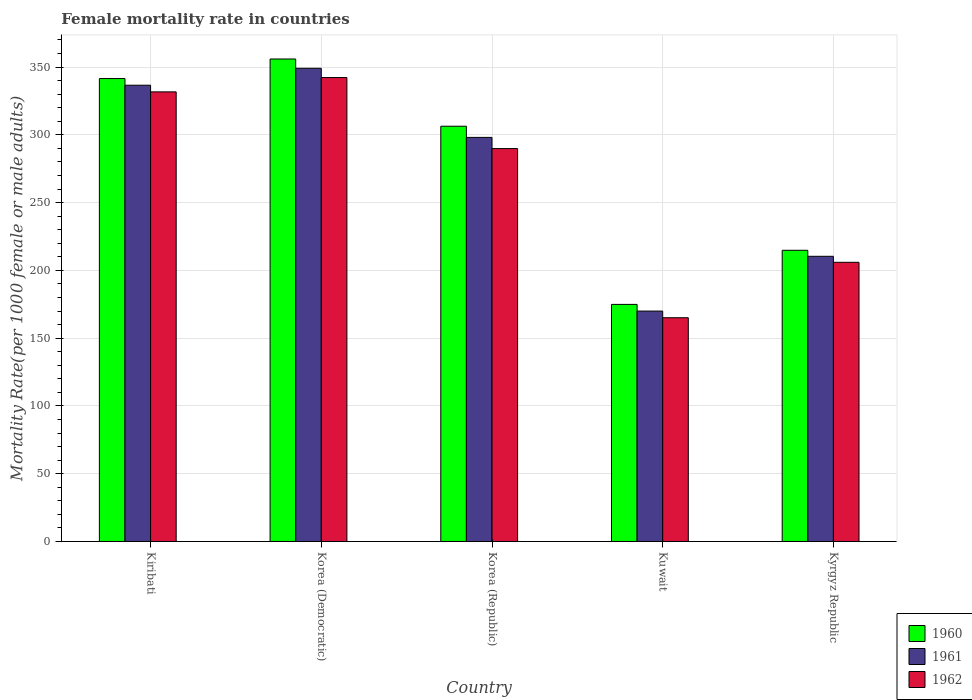How many groups of bars are there?
Give a very brief answer. 5. Are the number of bars on each tick of the X-axis equal?
Ensure brevity in your answer.  Yes. What is the label of the 5th group of bars from the left?
Ensure brevity in your answer.  Kyrgyz Republic. What is the female mortality rate in 1960 in Kuwait?
Your answer should be compact. 174.91. Across all countries, what is the maximum female mortality rate in 1961?
Ensure brevity in your answer.  349.13. Across all countries, what is the minimum female mortality rate in 1960?
Provide a short and direct response. 174.91. In which country was the female mortality rate in 1962 maximum?
Offer a terse response. Korea (Democratic). In which country was the female mortality rate in 1961 minimum?
Offer a terse response. Kuwait. What is the total female mortality rate in 1960 in the graph?
Keep it short and to the point. 1393.64. What is the difference between the female mortality rate in 1962 in Korea (Republic) and that in Kuwait?
Your response must be concise. 124.8. What is the difference between the female mortality rate in 1961 in Kyrgyz Republic and the female mortality rate in 1962 in Korea (Democratic)?
Your answer should be very brief. -131.89. What is the average female mortality rate in 1962 per country?
Offer a terse response. 266.99. What is the difference between the female mortality rate of/in 1960 and female mortality rate of/in 1961 in Kiribati?
Keep it short and to the point. 4.91. In how many countries, is the female mortality rate in 1961 greater than 330?
Make the answer very short. 2. What is the ratio of the female mortality rate in 1962 in Kiribati to that in Korea (Republic)?
Keep it short and to the point. 1.14. Is the difference between the female mortality rate in 1960 in Kiribati and Kuwait greater than the difference between the female mortality rate in 1961 in Kiribati and Kuwait?
Your answer should be very brief. No. What is the difference between the highest and the second highest female mortality rate in 1961?
Provide a succinct answer. 38.5. What is the difference between the highest and the lowest female mortality rate in 1962?
Ensure brevity in your answer.  177.21. Is the sum of the female mortality rate in 1962 in Kuwait and Kyrgyz Republic greater than the maximum female mortality rate in 1961 across all countries?
Provide a short and direct response. Yes. What does the 3rd bar from the left in Korea (Democratic) represents?
Make the answer very short. 1962. Is it the case that in every country, the sum of the female mortality rate in 1962 and female mortality rate in 1961 is greater than the female mortality rate in 1960?
Keep it short and to the point. Yes. How many bars are there?
Give a very brief answer. 15. Are all the bars in the graph horizontal?
Offer a very short reply. No. Does the graph contain any zero values?
Your response must be concise. No. How are the legend labels stacked?
Your answer should be compact. Vertical. What is the title of the graph?
Make the answer very short. Female mortality rate in countries. What is the label or title of the Y-axis?
Ensure brevity in your answer.  Mortality Rate(per 1000 female or male adults). What is the Mortality Rate(per 1000 female or male adults) of 1960 in Kiribati?
Provide a succinct answer. 341.55. What is the Mortality Rate(per 1000 female or male adults) of 1961 in Kiribati?
Offer a very short reply. 336.63. What is the Mortality Rate(per 1000 female or male adults) in 1962 in Kiribati?
Ensure brevity in your answer.  331.72. What is the Mortality Rate(per 1000 female or male adults) in 1960 in Korea (Democratic)?
Make the answer very short. 355.97. What is the Mortality Rate(per 1000 female or male adults) of 1961 in Korea (Democratic)?
Offer a very short reply. 349.13. What is the Mortality Rate(per 1000 female or male adults) in 1962 in Korea (Democratic)?
Provide a short and direct response. 342.29. What is the Mortality Rate(per 1000 female or male adults) in 1960 in Korea (Republic)?
Provide a short and direct response. 306.37. What is the Mortality Rate(per 1000 female or male adults) of 1961 in Korea (Republic)?
Keep it short and to the point. 298.13. What is the Mortality Rate(per 1000 female or male adults) of 1962 in Korea (Republic)?
Your response must be concise. 289.88. What is the Mortality Rate(per 1000 female or male adults) of 1960 in Kuwait?
Provide a short and direct response. 174.91. What is the Mortality Rate(per 1000 female or male adults) in 1961 in Kuwait?
Ensure brevity in your answer.  169.99. What is the Mortality Rate(per 1000 female or male adults) in 1962 in Kuwait?
Offer a very short reply. 165.08. What is the Mortality Rate(per 1000 female or male adults) in 1960 in Kyrgyz Republic?
Make the answer very short. 214.84. What is the Mortality Rate(per 1000 female or male adults) of 1961 in Kyrgyz Republic?
Provide a succinct answer. 210.4. What is the Mortality Rate(per 1000 female or male adults) of 1962 in Kyrgyz Republic?
Make the answer very short. 205.97. Across all countries, what is the maximum Mortality Rate(per 1000 female or male adults) of 1960?
Your answer should be compact. 355.97. Across all countries, what is the maximum Mortality Rate(per 1000 female or male adults) of 1961?
Provide a succinct answer. 349.13. Across all countries, what is the maximum Mortality Rate(per 1000 female or male adults) in 1962?
Provide a short and direct response. 342.29. Across all countries, what is the minimum Mortality Rate(per 1000 female or male adults) of 1960?
Your response must be concise. 174.91. Across all countries, what is the minimum Mortality Rate(per 1000 female or male adults) in 1961?
Provide a succinct answer. 169.99. Across all countries, what is the minimum Mortality Rate(per 1000 female or male adults) in 1962?
Offer a terse response. 165.08. What is the total Mortality Rate(per 1000 female or male adults) in 1960 in the graph?
Make the answer very short. 1393.64. What is the total Mortality Rate(per 1000 female or male adults) in 1961 in the graph?
Offer a terse response. 1364.29. What is the total Mortality Rate(per 1000 female or male adults) of 1962 in the graph?
Offer a terse response. 1334.93. What is the difference between the Mortality Rate(per 1000 female or male adults) in 1960 in Kiribati and that in Korea (Democratic)?
Keep it short and to the point. -14.43. What is the difference between the Mortality Rate(per 1000 female or male adults) in 1961 in Kiribati and that in Korea (Democratic)?
Your answer should be compact. -12.5. What is the difference between the Mortality Rate(per 1000 female or male adults) in 1962 in Kiribati and that in Korea (Democratic)?
Keep it short and to the point. -10.57. What is the difference between the Mortality Rate(per 1000 female or male adults) of 1960 in Kiribati and that in Korea (Republic)?
Your response must be concise. 35.17. What is the difference between the Mortality Rate(per 1000 female or male adults) of 1961 in Kiribati and that in Korea (Republic)?
Offer a terse response. 38.5. What is the difference between the Mortality Rate(per 1000 female or male adults) of 1962 in Kiribati and that in Korea (Republic)?
Your answer should be compact. 41.84. What is the difference between the Mortality Rate(per 1000 female or male adults) in 1960 in Kiribati and that in Kuwait?
Keep it short and to the point. 166.63. What is the difference between the Mortality Rate(per 1000 female or male adults) in 1961 in Kiribati and that in Kuwait?
Give a very brief answer. 166.64. What is the difference between the Mortality Rate(per 1000 female or male adults) in 1962 in Kiribati and that in Kuwait?
Give a very brief answer. 166.64. What is the difference between the Mortality Rate(per 1000 female or male adults) in 1960 in Kiribati and that in Kyrgyz Republic?
Offer a very short reply. 126.71. What is the difference between the Mortality Rate(per 1000 female or male adults) in 1961 in Kiribati and that in Kyrgyz Republic?
Your answer should be compact. 126.23. What is the difference between the Mortality Rate(per 1000 female or male adults) of 1962 in Kiribati and that in Kyrgyz Republic?
Offer a terse response. 125.75. What is the difference between the Mortality Rate(per 1000 female or male adults) in 1960 in Korea (Democratic) and that in Korea (Republic)?
Your response must be concise. 49.6. What is the difference between the Mortality Rate(per 1000 female or male adults) in 1961 in Korea (Democratic) and that in Korea (Republic)?
Provide a succinct answer. 51. What is the difference between the Mortality Rate(per 1000 female or male adults) in 1962 in Korea (Democratic) and that in Korea (Republic)?
Make the answer very short. 52.41. What is the difference between the Mortality Rate(per 1000 female or male adults) of 1960 in Korea (Democratic) and that in Kuwait?
Keep it short and to the point. 181.06. What is the difference between the Mortality Rate(per 1000 female or male adults) in 1961 in Korea (Democratic) and that in Kuwait?
Provide a succinct answer. 179.14. What is the difference between the Mortality Rate(per 1000 female or male adults) in 1962 in Korea (Democratic) and that in Kuwait?
Ensure brevity in your answer.  177.21. What is the difference between the Mortality Rate(per 1000 female or male adults) in 1960 in Korea (Democratic) and that in Kyrgyz Republic?
Your response must be concise. 141.13. What is the difference between the Mortality Rate(per 1000 female or male adults) of 1961 in Korea (Democratic) and that in Kyrgyz Republic?
Offer a very short reply. 138.73. What is the difference between the Mortality Rate(per 1000 female or male adults) in 1962 in Korea (Democratic) and that in Kyrgyz Republic?
Ensure brevity in your answer.  136.32. What is the difference between the Mortality Rate(per 1000 female or male adults) of 1960 in Korea (Republic) and that in Kuwait?
Provide a succinct answer. 131.46. What is the difference between the Mortality Rate(per 1000 female or male adults) of 1961 in Korea (Republic) and that in Kuwait?
Offer a terse response. 128.13. What is the difference between the Mortality Rate(per 1000 female or male adults) in 1962 in Korea (Republic) and that in Kuwait?
Provide a short and direct response. 124.8. What is the difference between the Mortality Rate(per 1000 female or male adults) in 1960 in Korea (Republic) and that in Kyrgyz Republic?
Give a very brief answer. 91.54. What is the difference between the Mortality Rate(per 1000 female or male adults) of 1961 in Korea (Republic) and that in Kyrgyz Republic?
Offer a terse response. 87.73. What is the difference between the Mortality Rate(per 1000 female or male adults) of 1962 in Korea (Republic) and that in Kyrgyz Republic?
Offer a terse response. 83.91. What is the difference between the Mortality Rate(per 1000 female or male adults) in 1960 in Kuwait and that in Kyrgyz Republic?
Your answer should be compact. -39.93. What is the difference between the Mortality Rate(per 1000 female or male adults) of 1961 in Kuwait and that in Kyrgyz Republic?
Make the answer very short. -40.41. What is the difference between the Mortality Rate(per 1000 female or male adults) in 1962 in Kuwait and that in Kyrgyz Republic?
Provide a short and direct response. -40.89. What is the difference between the Mortality Rate(per 1000 female or male adults) of 1960 in Kiribati and the Mortality Rate(per 1000 female or male adults) of 1961 in Korea (Democratic)?
Offer a terse response. -7.59. What is the difference between the Mortality Rate(per 1000 female or male adults) of 1960 in Kiribati and the Mortality Rate(per 1000 female or male adults) of 1962 in Korea (Democratic)?
Make the answer very short. -0.75. What is the difference between the Mortality Rate(per 1000 female or male adults) of 1961 in Kiribati and the Mortality Rate(per 1000 female or male adults) of 1962 in Korea (Democratic)?
Offer a very short reply. -5.66. What is the difference between the Mortality Rate(per 1000 female or male adults) in 1960 in Kiribati and the Mortality Rate(per 1000 female or male adults) in 1961 in Korea (Republic)?
Ensure brevity in your answer.  43.42. What is the difference between the Mortality Rate(per 1000 female or male adults) of 1960 in Kiribati and the Mortality Rate(per 1000 female or male adults) of 1962 in Korea (Republic)?
Give a very brief answer. 51.66. What is the difference between the Mortality Rate(per 1000 female or male adults) in 1961 in Kiribati and the Mortality Rate(per 1000 female or male adults) in 1962 in Korea (Republic)?
Offer a terse response. 46.75. What is the difference between the Mortality Rate(per 1000 female or male adults) in 1960 in Kiribati and the Mortality Rate(per 1000 female or male adults) in 1961 in Kuwait?
Ensure brevity in your answer.  171.55. What is the difference between the Mortality Rate(per 1000 female or male adults) of 1960 in Kiribati and the Mortality Rate(per 1000 female or male adults) of 1962 in Kuwait?
Offer a terse response. 176.47. What is the difference between the Mortality Rate(per 1000 female or male adults) of 1961 in Kiribati and the Mortality Rate(per 1000 female or male adults) of 1962 in Kuwait?
Make the answer very short. 171.55. What is the difference between the Mortality Rate(per 1000 female or male adults) in 1960 in Kiribati and the Mortality Rate(per 1000 female or male adults) in 1961 in Kyrgyz Republic?
Your response must be concise. 131.14. What is the difference between the Mortality Rate(per 1000 female or male adults) in 1960 in Kiribati and the Mortality Rate(per 1000 female or male adults) in 1962 in Kyrgyz Republic?
Provide a succinct answer. 135.58. What is the difference between the Mortality Rate(per 1000 female or male adults) in 1961 in Kiribati and the Mortality Rate(per 1000 female or male adults) in 1962 in Kyrgyz Republic?
Your response must be concise. 130.66. What is the difference between the Mortality Rate(per 1000 female or male adults) in 1960 in Korea (Democratic) and the Mortality Rate(per 1000 female or male adults) in 1961 in Korea (Republic)?
Ensure brevity in your answer.  57.84. What is the difference between the Mortality Rate(per 1000 female or male adults) in 1960 in Korea (Democratic) and the Mortality Rate(per 1000 female or male adults) in 1962 in Korea (Republic)?
Keep it short and to the point. 66.09. What is the difference between the Mortality Rate(per 1000 female or male adults) in 1961 in Korea (Democratic) and the Mortality Rate(per 1000 female or male adults) in 1962 in Korea (Republic)?
Your response must be concise. 59.25. What is the difference between the Mortality Rate(per 1000 female or male adults) of 1960 in Korea (Democratic) and the Mortality Rate(per 1000 female or male adults) of 1961 in Kuwait?
Your answer should be compact. 185.98. What is the difference between the Mortality Rate(per 1000 female or male adults) in 1960 in Korea (Democratic) and the Mortality Rate(per 1000 female or male adults) in 1962 in Kuwait?
Provide a short and direct response. 190.89. What is the difference between the Mortality Rate(per 1000 female or male adults) in 1961 in Korea (Democratic) and the Mortality Rate(per 1000 female or male adults) in 1962 in Kuwait?
Your answer should be compact. 184.05. What is the difference between the Mortality Rate(per 1000 female or male adults) in 1960 in Korea (Democratic) and the Mortality Rate(per 1000 female or male adults) in 1961 in Kyrgyz Republic?
Offer a terse response. 145.57. What is the difference between the Mortality Rate(per 1000 female or male adults) of 1960 in Korea (Democratic) and the Mortality Rate(per 1000 female or male adults) of 1962 in Kyrgyz Republic?
Your answer should be compact. 150. What is the difference between the Mortality Rate(per 1000 female or male adults) in 1961 in Korea (Democratic) and the Mortality Rate(per 1000 female or male adults) in 1962 in Kyrgyz Republic?
Your answer should be very brief. 143.16. What is the difference between the Mortality Rate(per 1000 female or male adults) of 1960 in Korea (Republic) and the Mortality Rate(per 1000 female or male adults) of 1961 in Kuwait?
Your answer should be compact. 136.38. What is the difference between the Mortality Rate(per 1000 female or male adults) of 1960 in Korea (Republic) and the Mortality Rate(per 1000 female or male adults) of 1962 in Kuwait?
Give a very brief answer. 141.3. What is the difference between the Mortality Rate(per 1000 female or male adults) of 1961 in Korea (Republic) and the Mortality Rate(per 1000 female or male adults) of 1962 in Kuwait?
Make the answer very short. 133.05. What is the difference between the Mortality Rate(per 1000 female or male adults) of 1960 in Korea (Republic) and the Mortality Rate(per 1000 female or male adults) of 1961 in Kyrgyz Republic?
Your response must be concise. 95.97. What is the difference between the Mortality Rate(per 1000 female or male adults) in 1960 in Korea (Republic) and the Mortality Rate(per 1000 female or male adults) in 1962 in Kyrgyz Republic?
Make the answer very short. 100.41. What is the difference between the Mortality Rate(per 1000 female or male adults) in 1961 in Korea (Republic) and the Mortality Rate(per 1000 female or male adults) in 1962 in Kyrgyz Republic?
Make the answer very short. 92.16. What is the difference between the Mortality Rate(per 1000 female or male adults) of 1960 in Kuwait and the Mortality Rate(per 1000 female or male adults) of 1961 in Kyrgyz Republic?
Ensure brevity in your answer.  -35.49. What is the difference between the Mortality Rate(per 1000 female or male adults) of 1960 in Kuwait and the Mortality Rate(per 1000 female or male adults) of 1962 in Kyrgyz Republic?
Provide a short and direct response. -31.06. What is the difference between the Mortality Rate(per 1000 female or male adults) of 1961 in Kuwait and the Mortality Rate(per 1000 female or male adults) of 1962 in Kyrgyz Republic?
Offer a very short reply. -35.97. What is the average Mortality Rate(per 1000 female or male adults) in 1960 per country?
Your answer should be very brief. 278.73. What is the average Mortality Rate(per 1000 female or male adults) of 1961 per country?
Your answer should be very brief. 272.86. What is the average Mortality Rate(per 1000 female or male adults) of 1962 per country?
Give a very brief answer. 266.99. What is the difference between the Mortality Rate(per 1000 female or male adults) of 1960 and Mortality Rate(per 1000 female or male adults) of 1961 in Kiribati?
Make the answer very short. 4.91. What is the difference between the Mortality Rate(per 1000 female or male adults) of 1960 and Mortality Rate(per 1000 female or male adults) of 1962 in Kiribati?
Offer a terse response. 9.83. What is the difference between the Mortality Rate(per 1000 female or male adults) of 1961 and Mortality Rate(per 1000 female or male adults) of 1962 in Kiribati?
Offer a terse response. 4.91. What is the difference between the Mortality Rate(per 1000 female or male adults) of 1960 and Mortality Rate(per 1000 female or male adults) of 1961 in Korea (Democratic)?
Your answer should be compact. 6.84. What is the difference between the Mortality Rate(per 1000 female or male adults) of 1960 and Mortality Rate(per 1000 female or male adults) of 1962 in Korea (Democratic)?
Your response must be concise. 13.68. What is the difference between the Mortality Rate(per 1000 female or male adults) in 1961 and Mortality Rate(per 1000 female or male adults) in 1962 in Korea (Democratic)?
Keep it short and to the point. 6.84. What is the difference between the Mortality Rate(per 1000 female or male adults) of 1960 and Mortality Rate(per 1000 female or male adults) of 1961 in Korea (Republic)?
Your answer should be very brief. 8.25. What is the difference between the Mortality Rate(per 1000 female or male adults) in 1960 and Mortality Rate(per 1000 female or male adults) in 1962 in Korea (Republic)?
Your answer should be compact. 16.49. What is the difference between the Mortality Rate(per 1000 female or male adults) of 1961 and Mortality Rate(per 1000 female or male adults) of 1962 in Korea (Republic)?
Offer a terse response. 8.25. What is the difference between the Mortality Rate(per 1000 female or male adults) of 1960 and Mortality Rate(per 1000 female or male adults) of 1961 in Kuwait?
Give a very brief answer. 4.92. What is the difference between the Mortality Rate(per 1000 female or male adults) in 1960 and Mortality Rate(per 1000 female or male adults) in 1962 in Kuwait?
Ensure brevity in your answer.  9.83. What is the difference between the Mortality Rate(per 1000 female or male adults) in 1961 and Mortality Rate(per 1000 female or male adults) in 1962 in Kuwait?
Your answer should be very brief. 4.92. What is the difference between the Mortality Rate(per 1000 female or male adults) in 1960 and Mortality Rate(per 1000 female or male adults) in 1961 in Kyrgyz Republic?
Your answer should be compact. 4.43. What is the difference between the Mortality Rate(per 1000 female or male adults) in 1960 and Mortality Rate(per 1000 female or male adults) in 1962 in Kyrgyz Republic?
Provide a short and direct response. 8.87. What is the difference between the Mortality Rate(per 1000 female or male adults) of 1961 and Mortality Rate(per 1000 female or male adults) of 1962 in Kyrgyz Republic?
Ensure brevity in your answer.  4.43. What is the ratio of the Mortality Rate(per 1000 female or male adults) in 1960 in Kiribati to that in Korea (Democratic)?
Give a very brief answer. 0.96. What is the ratio of the Mortality Rate(per 1000 female or male adults) in 1961 in Kiribati to that in Korea (Democratic)?
Offer a terse response. 0.96. What is the ratio of the Mortality Rate(per 1000 female or male adults) of 1962 in Kiribati to that in Korea (Democratic)?
Your answer should be compact. 0.97. What is the ratio of the Mortality Rate(per 1000 female or male adults) in 1960 in Kiribati to that in Korea (Republic)?
Provide a succinct answer. 1.11. What is the ratio of the Mortality Rate(per 1000 female or male adults) of 1961 in Kiribati to that in Korea (Republic)?
Your response must be concise. 1.13. What is the ratio of the Mortality Rate(per 1000 female or male adults) of 1962 in Kiribati to that in Korea (Republic)?
Your answer should be very brief. 1.14. What is the ratio of the Mortality Rate(per 1000 female or male adults) in 1960 in Kiribati to that in Kuwait?
Ensure brevity in your answer.  1.95. What is the ratio of the Mortality Rate(per 1000 female or male adults) of 1961 in Kiribati to that in Kuwait?
Provide a succinct answer. 1.98. What is the ratio of the Mortality Rate(per 1000 female or male adults) in 1962 in Kiribati to that in Kuwait?
Offer a terse response. 2.01. What is the ratio of the Mortality Rate(per 1000 female or male adults) of 1960 in Kiribati to that in Kyrgyz Republic?
Your answer should be very brief. 1.59. What is the ratio of the Mortality Rate(per 1000 female or male adults) of 1961 in Kiribati to that in Kyrgyz Republic?
Ensure brevity in your answer.  1.6. What is the ratio of the Mortality Rate(per 1000 female or male adults) in 1962 in Kiribati to that in Kyrgyz Republic?
Give a very brief answer. 1.61. What is the ratio of the Mortality Rate(per 1000 female or male adults) of 1960 in Korea (Democratic) to that in Korea (Republic)?
Your answer should be very brief. 1.16. What is the ratio of the Mortality Rate(per 1000 female or male adults) of 1961 in Korea (Democratic) to that in Korea (Republic)?
Your answer should be very brief. 1.17. What is the ratio of the Mortality Rate(per 1000 female or male adults) of 1962 in Korea (Democratic) to that in Korea (Republic)?
Provide a short and direct response. 1.18. What is the ratio of the Mortality Rate(per 1000 female or male adults) in 1960 in Korea (Democratic) to that in Kuwait?
Make the answer very short. 2.04. What is the ratio of the Mortality Rate(per 1000 female or male adults) of 1961 in Korea (Democratic) to that in Kuwait?
Provide a short and direct response. 2.05. What is the ratio of the Mortality Rate(per 1000 female or male adults) in 1962 in Korea (Democratic) to that in Kuwait?
Your answer should be very brief. 2.07. What is the ratio of the Mortality Rate(per 1000 female or male adults) in 1960 in Korea (Democratic) to that in Kyrgyz Republic?
Offer a very short reply. 1.66. What is the ratio of the Mortality Rate(per 1000 female or male adults) in 1961 in Korea (Democratic) to that in Kyrgyz Republic?
Make the answer very short. 1.66. What is the ratio of the Mortality Rate(per 1000 female or male adults) of 1962 in Korea (Democratic) to that in Kyrgyz Republic?
Provide a short and direct response. 1.66. What is the ratio of the Mortality Rate(per 1000 female or male adults) of 1960 in Korea (Republic) to that in Kuwait?
Provide a succinct answer. 1.75. What is the ratio of the Mortality Rate(per 1000 female or male adults) of 1961 in Korea (Republic) to that in Kuwait?
Make the answer very short. 1.75. What is the ratio of the Mortality Rate(per 1000 female or male adults) in 1962 in Korea (Republic) to that in Kuwait?
Give a very brief answer. 1.76. What is the ratio of the Mortality Rate(per 1000 female or male adults) of 1960 in Korea (Republic) to that in Kyrgyz Republic?
Offer a very short reply. 1.43. What is the ratio of the Mortality Rate(per 1000 female or male adults) in 1961 in Korea (Republic) to that in Kyrgyz Republic?
Make the answer very short. 1.42. What is the ratio of the Mortality Rate(per 1000 female or male adults) of 1962 in Korea (Republic) to that in Kyrgyz Republic?
Your response must be concise. 1.41. What is the ratio of the Mortality Rate(per 1000 female or male adults) in 1960 in Kuwait to that in Kyrgyz Republic?
Provide a short and direct response. 0.81. What is the ratio of the Mortality Rate(per 1000 female or male adults) in 1961 in Kuwait to that in Kyrgyz Republic?
Ensure brevity in your answer.  0.81. What is the ratio of the Mortality Rate(per 1000 female or male adults) of 1962 in Kuwait to that in Kyrgyz Republic?
Ensure brevity in your answer.  0.8. What is the difference between the highest and the second highest Mortality Rate(per 1000 female or male adults) of 1960?
Offer a very short reply. 14.43. What is the difference between the highest and the second highest Mortality Rate(per 1000 female or male adults) in 1961?
Keep it short and to the point. 12.5. What is the difference between the highest and the second highest Mortality Rate(per 1000 female or male adults) in 1962?
Your answer should be very brief. 10.57. What is the difference between the highest and the lowest Mortality Rate(per 1000 female or male adults) in 1960?
Ensure brevity in your answer.  181.06. What is the difference between the highest and the lowest Mortality Rate(per 1000 female or male adults) of 1961?
Your response must be concise. 179.14. What is the difference between the highest and the lowest Mortality Rate(per 1000 female or male adults) of 1962?
Make the answer very short. 177.21. 